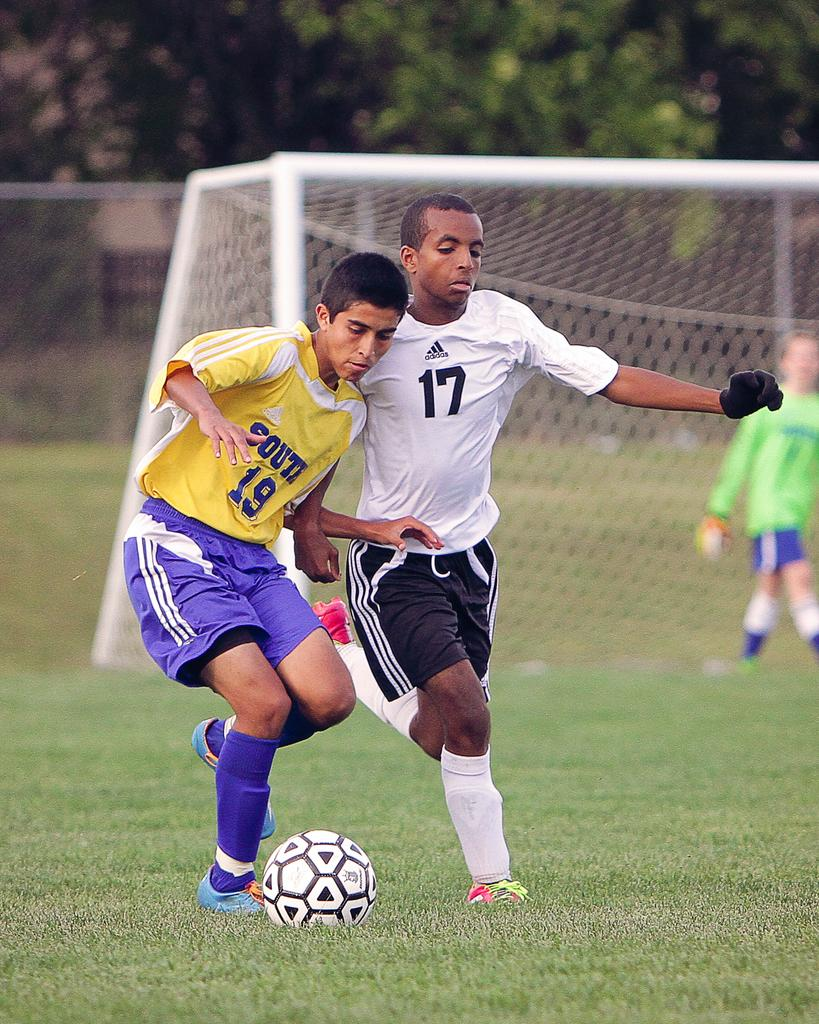What are the two men in the image doing? The two men in the image are running. What object is on the ground in the image? There is a ball on the ground in the image. What is happening in the background of the image? There is a person walking in the background of the image, and grass and trees are visible. How would you describe the appearance of the background? The background appears blurry. What type of brass instrument is being played by the snake in the image? There is no snake or brass instrument present in the image. 